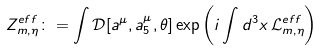Convert formula to latex. <formula><loc_0><loc_0><loc_500><loc_500>Z ^ { e f f } _ { m , \eta } \colon = \int \mathcal { D } [ a ^ { \mu } , a ^ { \mu } _ { 5 } , \theta ] \exp \left ( { i } \int d ^ { 3 } x \, \mathcal { L } ^ { e f f } _ { m , \eta } \right )</formula> 